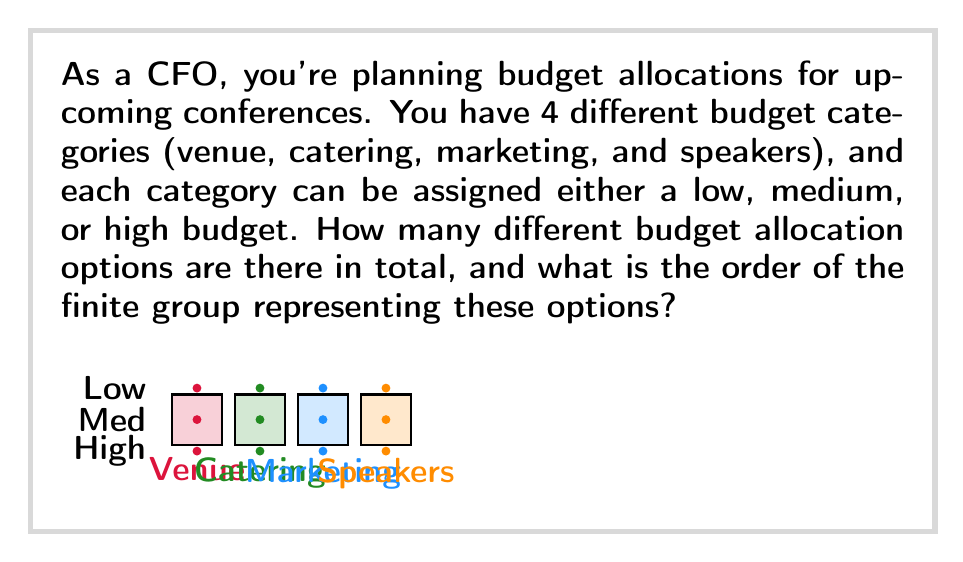Can you answer this question? Let's approach this step-by-step:

1) First, we need to determine the number of possible budget allocation options:
   - We have 4 categories (venue, catering, marketing, and speakers)
   - Each category has 3 options (low, medium, high)

2) This scenario can be represented as a combination of independent choices. For each category, we have 3 choices, and we need to make this choice 4 times (once for each category).

3) In combinatorics, this is known as the multiplication principle. The total number of possibilities is:

   $$ 3 \times 3 \times 3 \times 3 = 3^4 = 81 $$

4) Now, we need to consider how this relates to group theory. Each possible budget allocation can be thought of as an element in a group, where the group operation could be defined as "changing from one allocation to another".

5) The number of elements in this group is 81, as we calculated above.

6) In group theory, the number of elements in a finite group is called the order of the group.

Therefore, the order of the finite group representing these budget allocation options is 81.
Answer: 81 